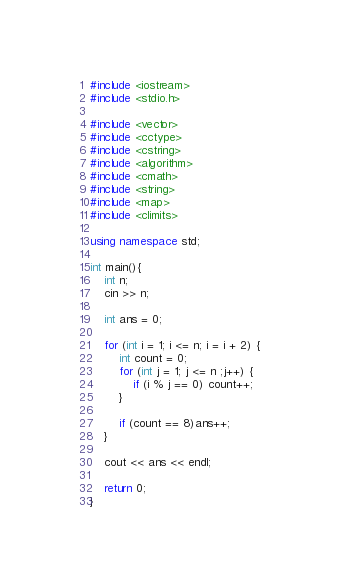Convert code to text. <code><loc_0><loc_0><loc_500><loc_500><_C++_>#include <iostream>
#include <stdio.h>

#include <vector>
#include <cctype>
#include <cstring>
#include <algorithm>
#include <cmath>
#include <string>
#include <map>
#include <climits>

using namespace std;

int main(){
	int n;
	cin >> n;

	int ans = 0;

	for (int i = 1; i <= n; i = i + 2) {
		int count = 0;
		for (int j = 1; j <= n ;j++) {
			if (i % j == 0) count++;
		}

		if (count == 8)ans++;
	}

	cout << ans << endl;

	return 0;
}</code> 